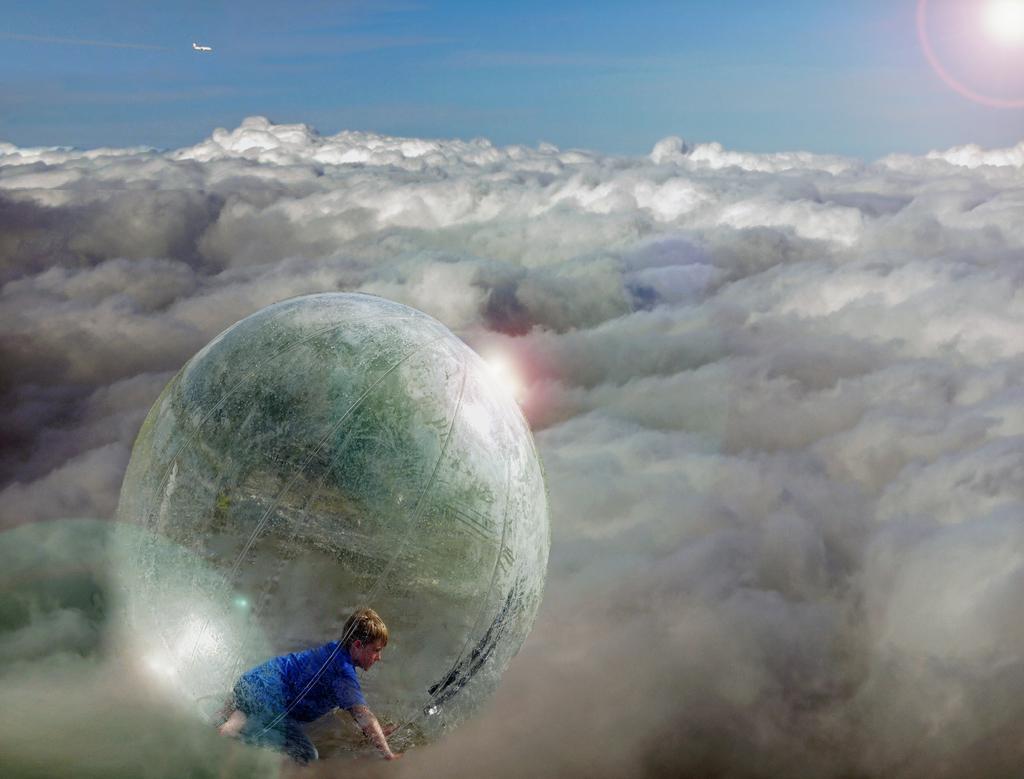Could you give a brief overview of what you see in this image? This an edited image, in this image there are clouds and there is a kid inside a balloon, in the background there is an airplane flying in the sky. 